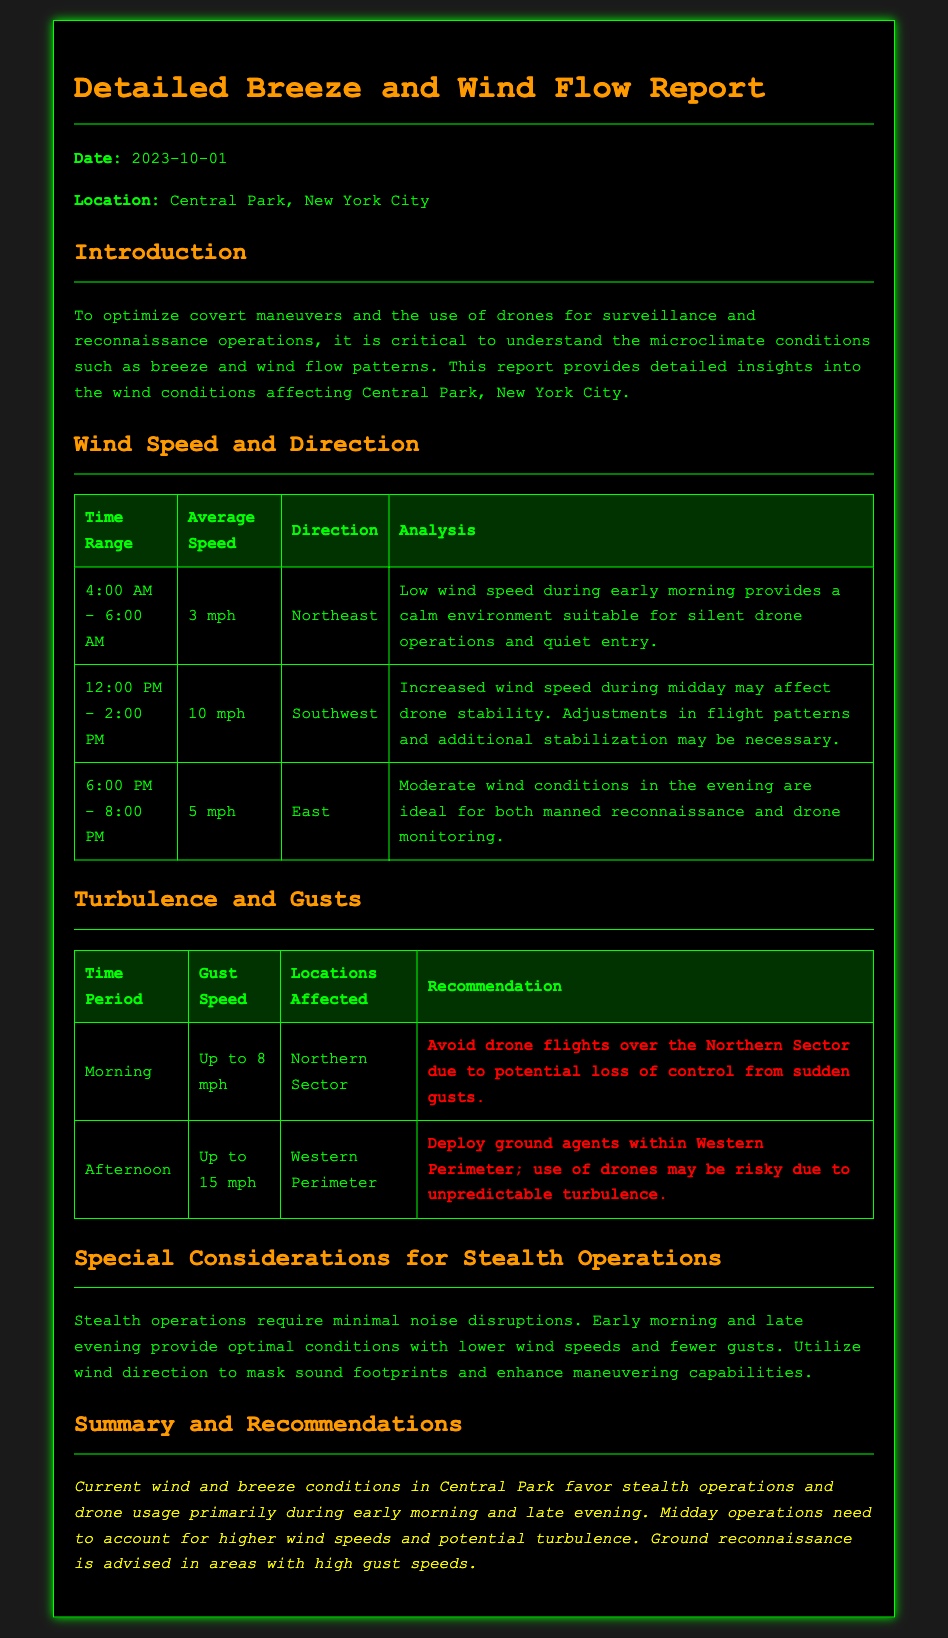What is the date of the report? The date is provided in the document as part of the report header.
Answer: 2023-10-01 What was the average wind speed between 4:00 AM and 6:00 AM? The average speed is stated in the wind speed section for that specific time range.
Answer: 3 mph What direction was the wind blowing during the afternoon? The direction is specified in the wind speed table for the 12:00 PM - 2:00 PM time slot.
Answer: Southwest What gust speed is recorded for the morning period? The gust speed is noted in the turbulence and gusts section for the morning period.
Answer: Up to 8 mph What part of Central Park should be avoided for drone flights in the morning? The document highlights specific locations affected by gusts in the turbulence table.
Answer: Northern Sector During which times are stealth operations most favored? The document outlines optimal conditions for stealth operations within the special considerations section.
Answer: Early morning and late evening What is the wind analysis during the 6:00 PM to 8:00 PM time slot? The analysis for this time period is provided in the wind speed table.
Answer: Ideal for both manned reconnaissance and drone monitoring What is recommended for the Western Perimeter during afternoon turbulence? The document outlines specific actions to take in the Western Perimeter area.
Answer: Deploy ground agents What overall recommendation is given regarding midday operations? A recommendation is provided in the summary and recommendations section regarding midday operations.
Answer: Account for higher wind speeds and potential turbulence 